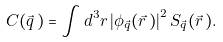Convert formula to latex. <formula><loc_0><loc_0><loc_500><loc_500>C ( \vec { q } \, ) = \int d ^ { 3 } r \left | \phi _ { \vec { q } } ( \vec { r } \, ) \right | ^ { 2 } S _ { \vec { q } } ( \vec { r } \, ) .</formula> 